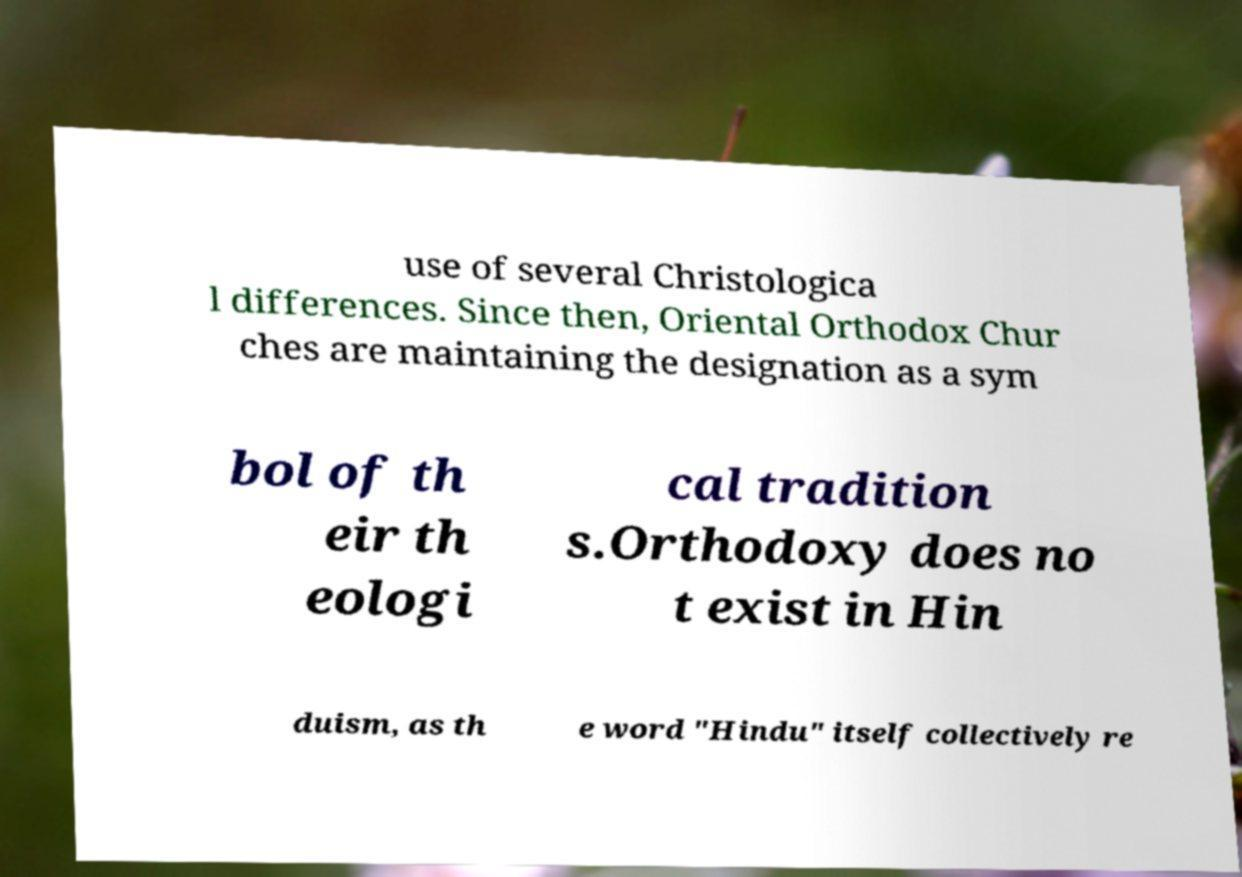Please read and relay the text visible in this image. What does it say? use of several Christologica l differences. Since then, Oriental Orthodox Chur ches are maintaining the designation as a sym bol of th eir th eologi cal tradition s.Orthodoxy does no t exist in Hin duism, as th e word "Hindu" itself collectively re 